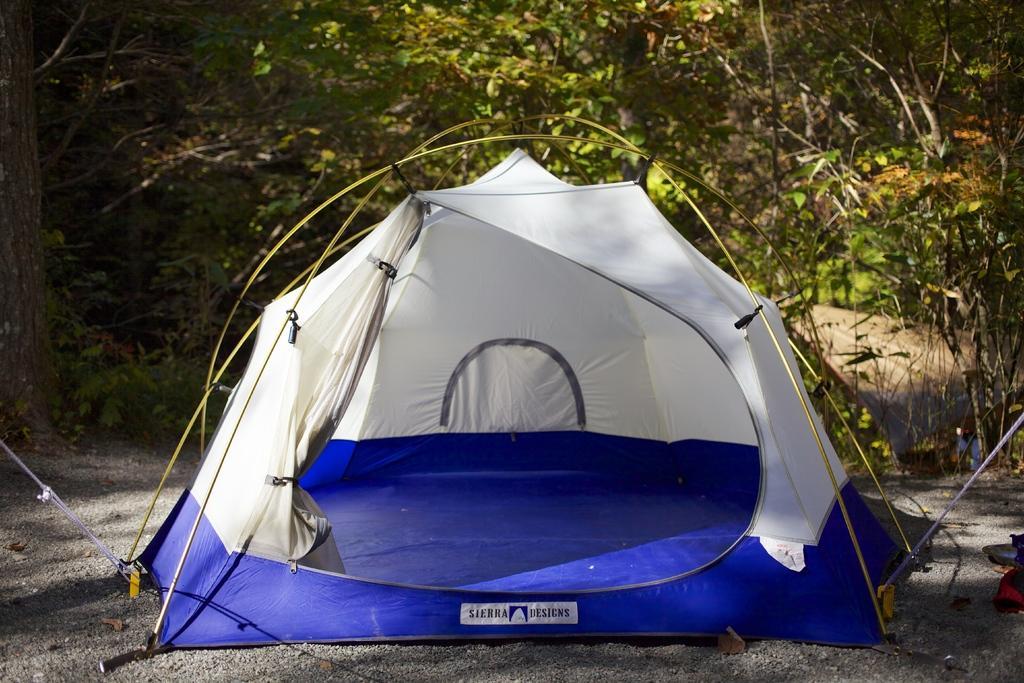How would you summarize this image in a sentence or two? Here we can see camping tent with ropes on the surface. Background we can see leaves. 